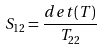Convert formula to latex. <formula><loc_0><loc_0><loc_500><loc_500>S _ { 1 2 } = \frac { d e t ( T ) } { T _ { 2 2 } }</formula> 